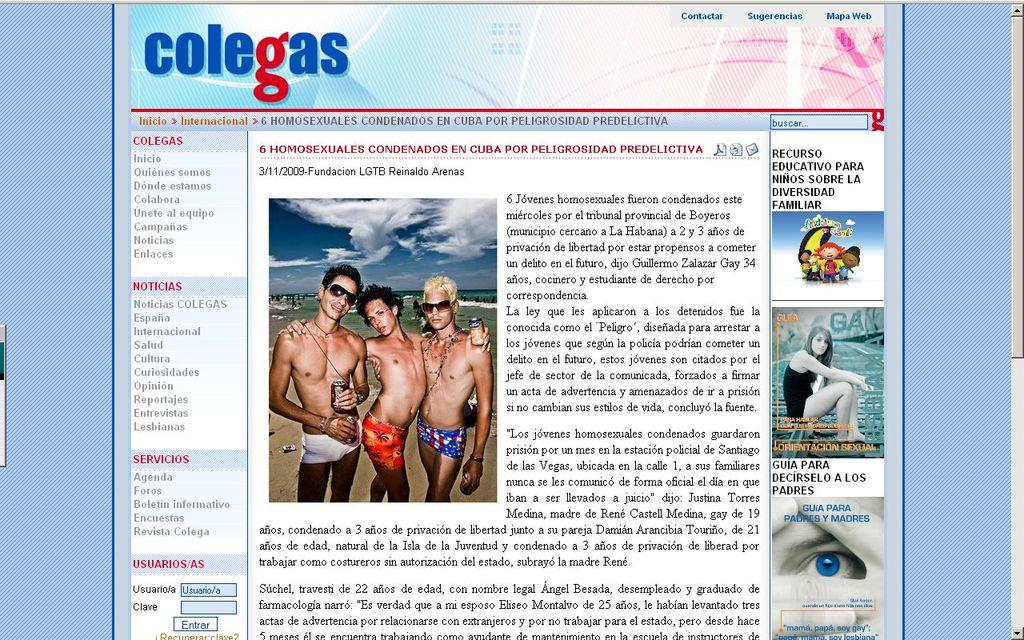What is the main object in the image? There is a screen in the image. What can be seen on the screen? There are people visible on the screen. What additional information is displayed on the screen? There is some information visible on the screen. Where is the mine located in the image? There is no mine present in the image. Is there a river flowing near the gate in the image? There is no gate or river present in the image. 